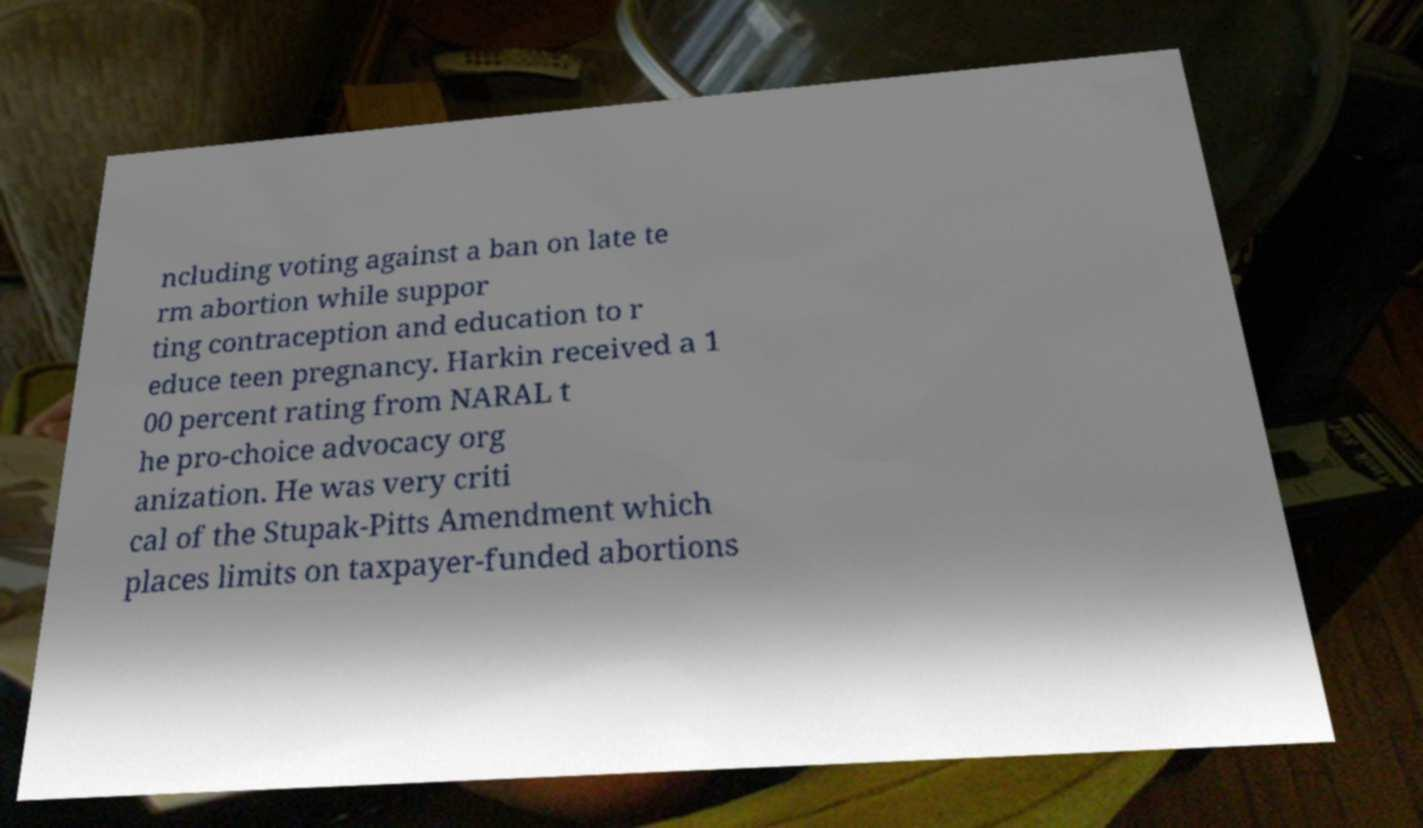Can you read and provide the text displayed in the image?This photo seems to have some interesting text. Can you extract and type it out for me? ncluding voting against a ban on late te rm abortion while suppor ting contraception and education to r educe teen pregnancy. Harkin received a 1 00 percent rating from NARAL t he pro-choice advocacy org anization. He was very criti cal of the Stupak-Pitts Amendment which places limits on taxpayer-funded abortions 